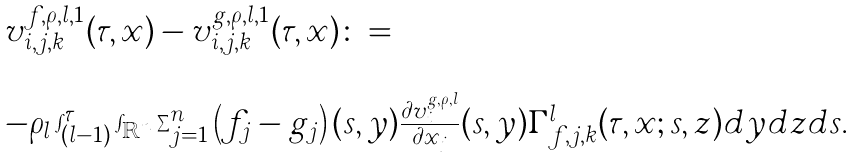<formula> <loc_0><loc_0><loc_500><loc_500>\begin{array} { l l } v ^ { f , \rho , l , 1 } _ { i , j , k } ( \tau , x ) - v ^ { g , \rho , l , 1 } _ { i , j , k } ( \tau , x ) \colon = \\ \\ - \rho _ { l } \int _ { ( l - 1 ) } ^ { \tau } \int _ { { \mathbb { R } } ^ { n } } \sum _ { j = 1 } ^ { n } \left ( f _ { j } - g _ { j } \right ) ( s , y ) \frac { \partial v ^ { g , \rho , l } _ { i } } { \partial x _ { j } } ( s , y ) \Gamma ^ { l } _ { f , j , k } ( \tau , x ; s , z ) d y d z d s . \end{array}</formula> 